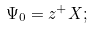Convert formula to latex. <formula><loc_0><loc_0><loc_500><loc_500>\Psi _ { 0 } = z ^ { + } X ;</formula> 